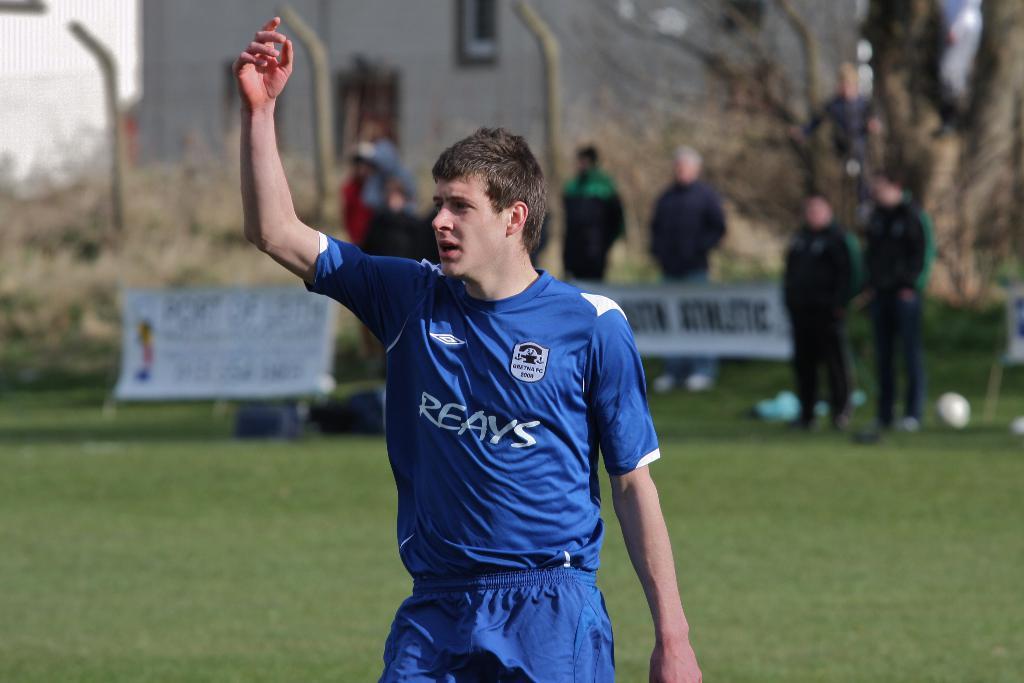What team does the man in blue play for?
Keep it short and to the point. Reays. 